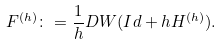<formula> <loc_0><loc_0><loc_500><loc_500>F ^ { ( h ) } \colon = \frac { 1 } { h } D W ( I d + h H ^ { ( h ) } ) .</formula> 